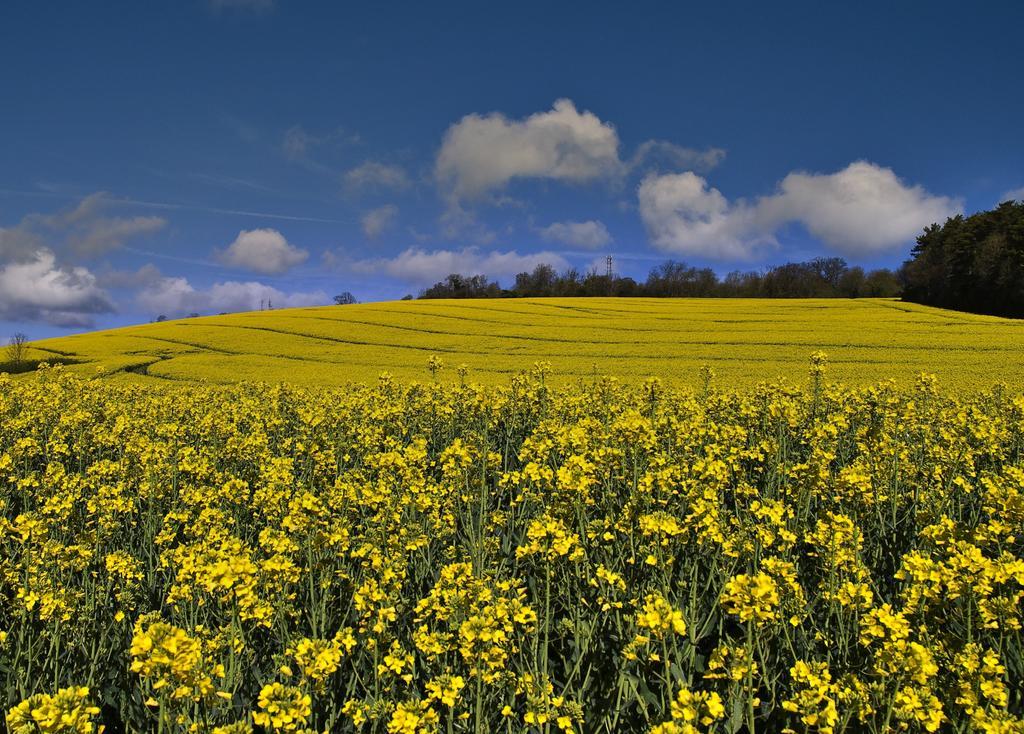In one or two sentences, can you explain what this image depicts? In this picture we can see some plants and flowers in the front, in the background there are some trees, we can see the sky at the top of the picture. 